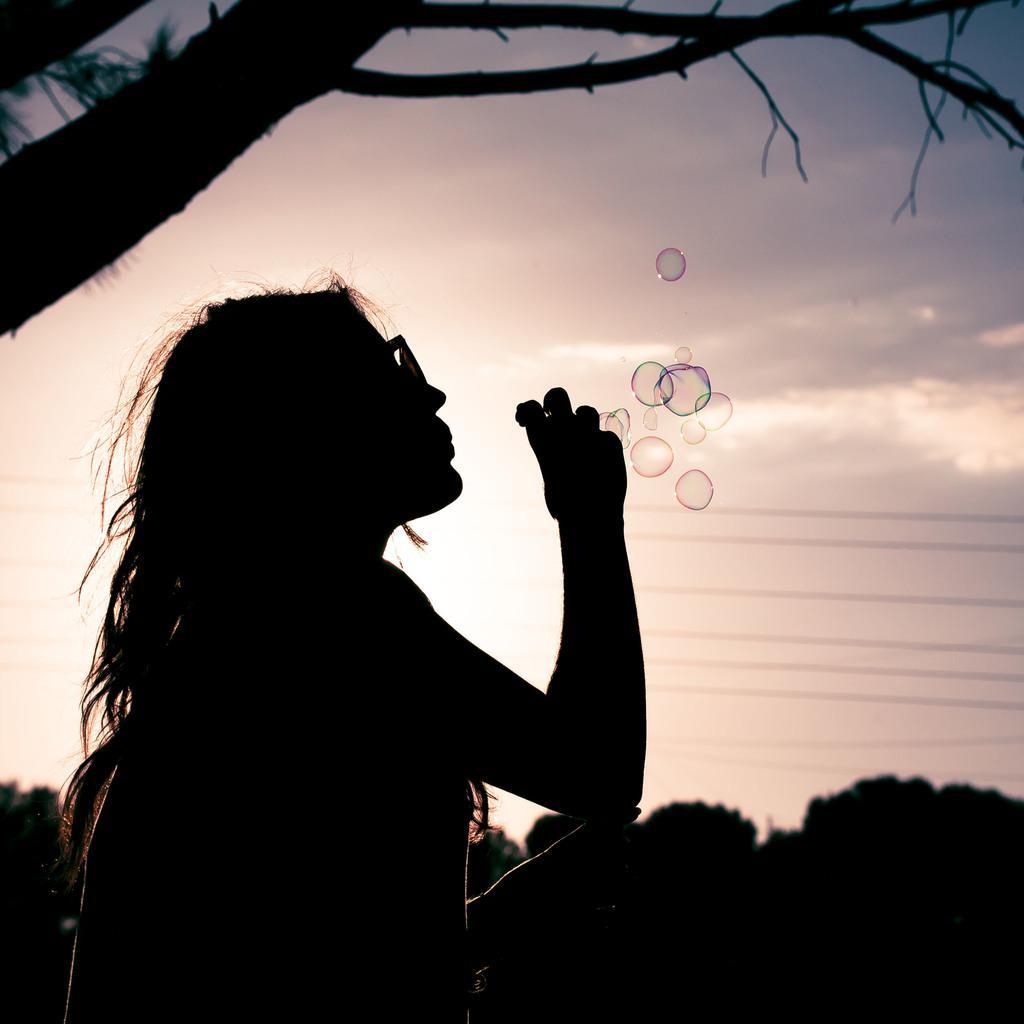In one or two sentences, can you explain what this image depicts? In the image there is a woman, she is blowing the bubbles and the background of the woman is blur. 